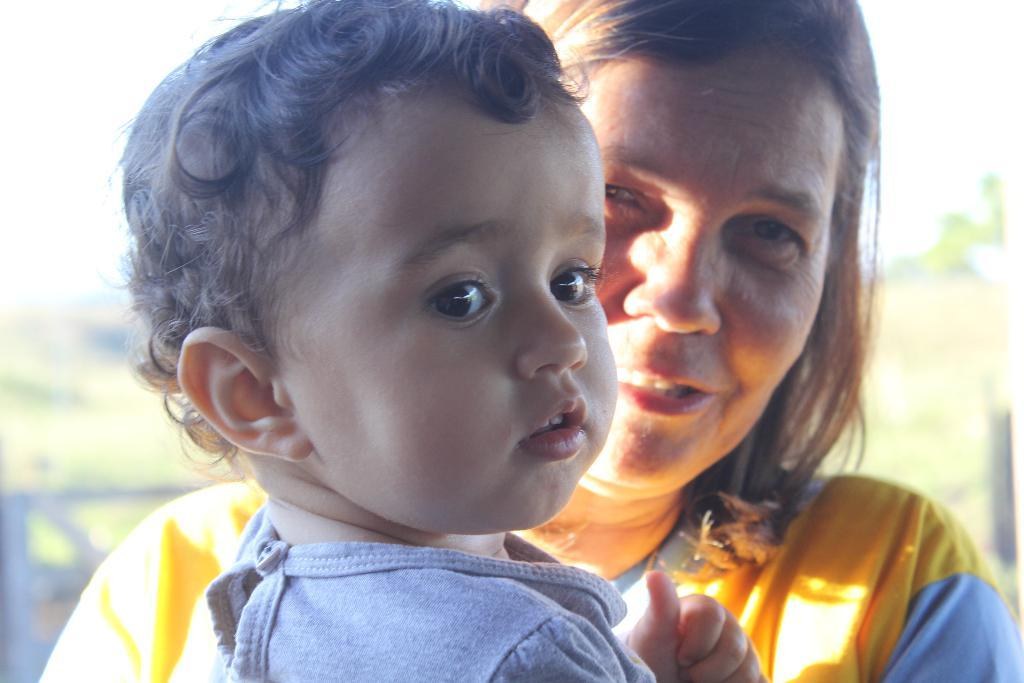Who is present in the image? There is a boy and a person in the image. Can you describe the boy in the image? The provided facts do not give specific details about the boy's appearance or actions. What can be observed about the background of the image? The background of the image is blurred. What type of flower can be seen growing in the snow in the image? There is no flower or snow present in the image; it features a boy and a person with a blurred background. 